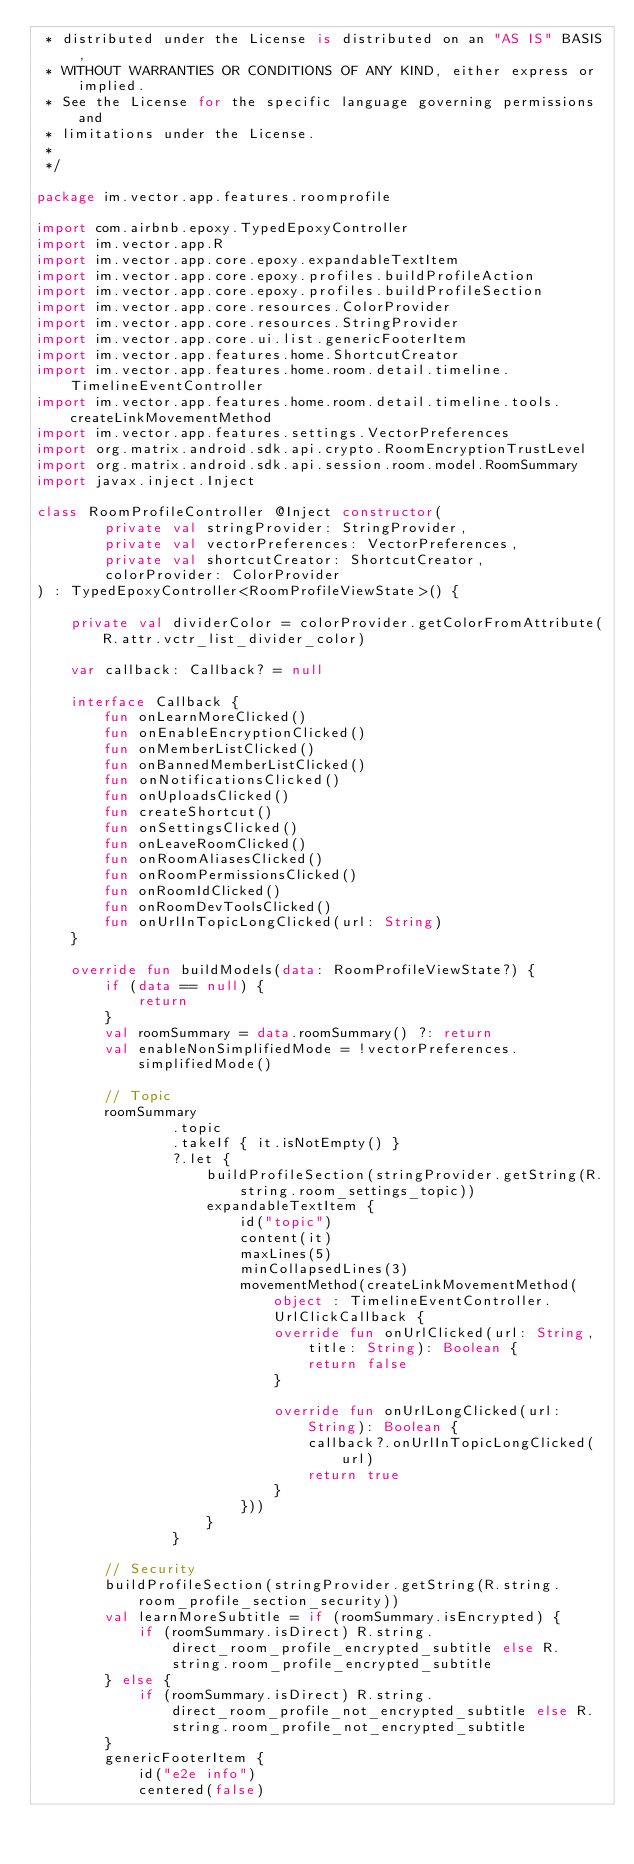Convert code to text. <code><loc_0><loc_0><loc_500><loc_500><_Kotlin_> * distributed under the License is distributed on an "AS IS" BASIS,
 * WITHOUT WARRANTIES OR CONDITIONS OF ANY KIND, either express or implied.
 * See the License for the specific language governing permissions and
 * limitations under the License.
 *
 */

package im.vector.app.features.roomprofile

import com.airbnb.epoxy.TypedEpoxyController
import im.vector.app.R
import im.vector.app.core.epoxy.expandableTextItem
import im.vector.app.core.epoxy.profiles.buildProfileAction
import im.vector.app.core.epoxy.profiles.buildProfileSection
import im.vector.app.core.resources.ColorProvider
import im.vector.app.core.resources.StringProvider
import im.vector.app.core.ui.list.genericFooterItem
import im.vector.app.features.home.ShortcutCreator
import im.vector.app.features.home.room.detail.timeline.TimelineEventController
import im.vector.app.features.home.room.detail.timeline.tools.createLinkMovementMethod
import im.vector.app.features.settings.VectorPreferences
import org.matrix.android.sdk.api.crypto.RoomEncryptionTrustLevel
import org.matrix.android.sdk.api.session.room.model.RoomSummary
import javax.inject.Inject

class RoomProfileController @Inject constructor(
        private val stringProvider: StringProvider,
        private val vectorPreferences: VectorPreferences,
        private val shortcutCreator: ShortcutCreator,
        colorProvider: ColorProvider
) : TypedEpoxyController<RoomProfileViewState>() {

    private val dividerColor = colorProvider.getColorFromAttribute(R.attr.vctr_list_divider_color)

    var callback: Callback? = null

    interface Callback {
        fun onLearnMoreClicked()
        fun onEnableEncryptionClicked()
        fun onMemberListClicked()
        fun onBannedMemberListClicked()
        fun onNotificationsClicked()
        fun onUploadsClicked()
        fun createShortcut()
        fun onSettingsClicked()
        fun onLeaveRoomClicked()
        fun onRoomAliasesClicked()
        fun onRoomPermissionsClicked()
        fun onRoomIdClicked()
        fun onRoomDevToolsClicked()
        fun onUrlInTopicLongClicked(url: String)
    }

    override fun buildModels(data: RoomProfileViewState?) {
        if (data == null) {
            return
        }
        val roomSummary = data.roomSummary() ?: return
        val enableNonSimplifiedMode = !vectorPreferences.simplifiedMode()

        // Topic
        roomSummary
                .topic
                .takeIf { it.isNotEmpty() }
                ?.let {
                    buildProfileSection(stringProvider.getString(R.string.room_settings_topic))
                    expandableTextItem {
                        id("topic")
                        content(it)
                        maxLines(5)
                        minCollapsedLines(3)
                        movementMethod(createLinkMovementMethod(object : TimelineEventController.UrlClickCallback {
                            override fun onUrlClicked(url: String, title: String): Boolean {
                                return false
                            }

                            override fun onUrlLongClicked(url: String): Boolean {
                                callback?.onUrlInTopicLongClicked(url)
                                return true
                            }
                        }))
                    }
                }

        // Security
        buildProfileSection(stringProvider.getString(R.string.room_profile_section_security))
        val learnMoreSubtitle = if (roomSummary.isEncrypted) {
            if (roomSummary.isDirect) R.string.direct_room_profile_encrypted_subtitle else R.string.room_profile_encrypted_subtitle
        } else {
            if (roomSummary.isDirect) R.string.direct_room_profile_not_encrypted_subtitle else R.string.room_profile_not_encrypted_subtitle
        }
        genericFooterItem {
            id("e2e info")
            centered(false)</code> 